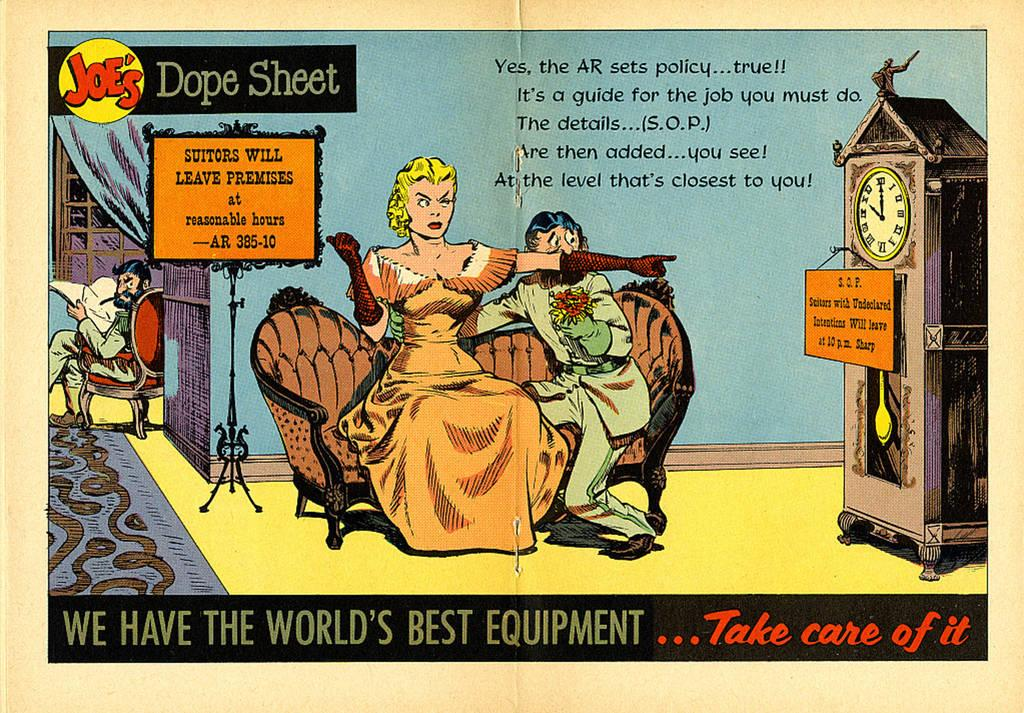<image>
Give a short and clear explanation of the subsequent image. Cartoon poster which says "We Have the World's Best Equipment" on the bottom. 